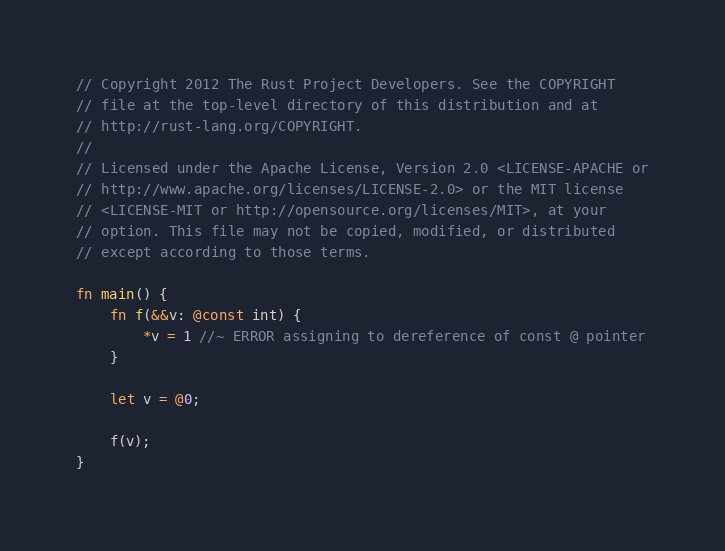<code> <loc_0><loc_0><loc_500><loc_500><_Rust_>// Copyright 2012 The Rust Project Developers. See the COPYRIGHT
// file at the top-level directory of this distribution and at
// http://rust-lang.org/COPYRIGHT.
//
// Licensed under the Apache License, Version 2.0 <LICENSE-APACHE or
// http://www.apache.org/licenses/LICENSE-2.0> or the MIT license
// <LICENSE-MIT or http://opensource.org/licenses/MIT>, at your
// option. This file may not be copied, modified, or distributed
// except according to those terms.

fn main() {
    fn f(&&v: @const int) {
        *v = 1 //~ ERROR assigning to dereference of const @ pointer
    }

    let v = @0;

    f(v);
}
</code> 